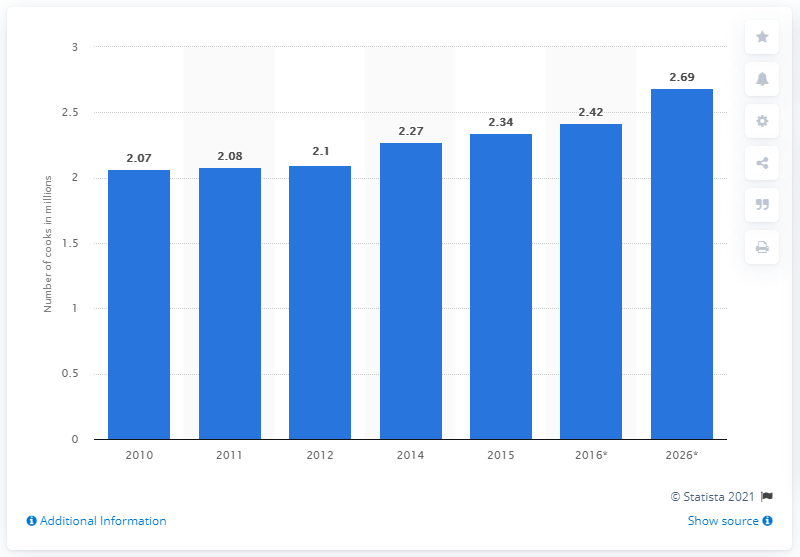Highlight a few significant elements in this photo. The forecast for the number of cooks in the U.S. restaurant industry by 2026 is 2.69 million. 